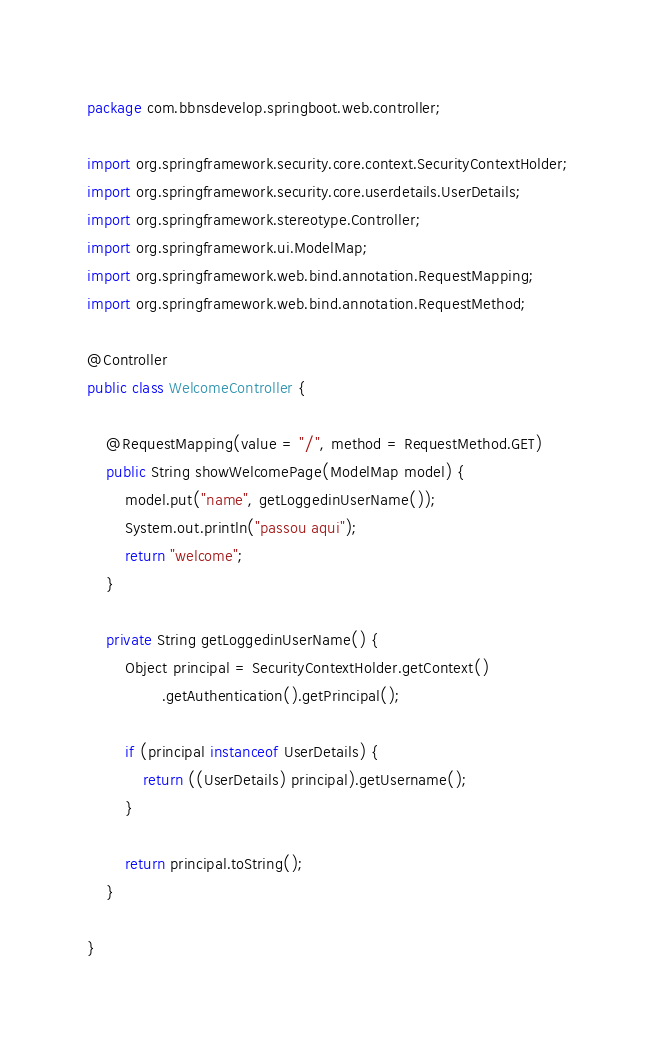<code> <loc_0><loc_0><loc_500><loc_500><_Java_>package com.bbnsdevelop.springboot.web.controller;

import org.springframework.security.core.context.SecurityContextHolder;
import org.springframework.security.core.userdetails.UserDetails;
import org.springframework.stereotype.Controller;
import org.springframework.ui.ModelMap;
import org.springframework.web.bind.annotation.RequestMapping;
import org.springframework.web.bind.annotation.RequestMethod;

@Controller
public class WelcomeController {

	@RequestMapping(value = "/", method = RequestMethod.GET)
	public String showWelcomePage(ModelMap model) {
		model.put("name", getLoggedinUserName());
		System.out.println("passou aqui");
		return "welcome";
	}

	private String getLoggedinUserName() {
		Object principal = SecurityContextHolder.getContext()
				.getAuthentication().getPrincipal();
		
		if (principal instanceof UserDetails) {
			return ((UserDetails) principal).getUsername();
		}
		
		return principal.toString();
	}

}
</code> 